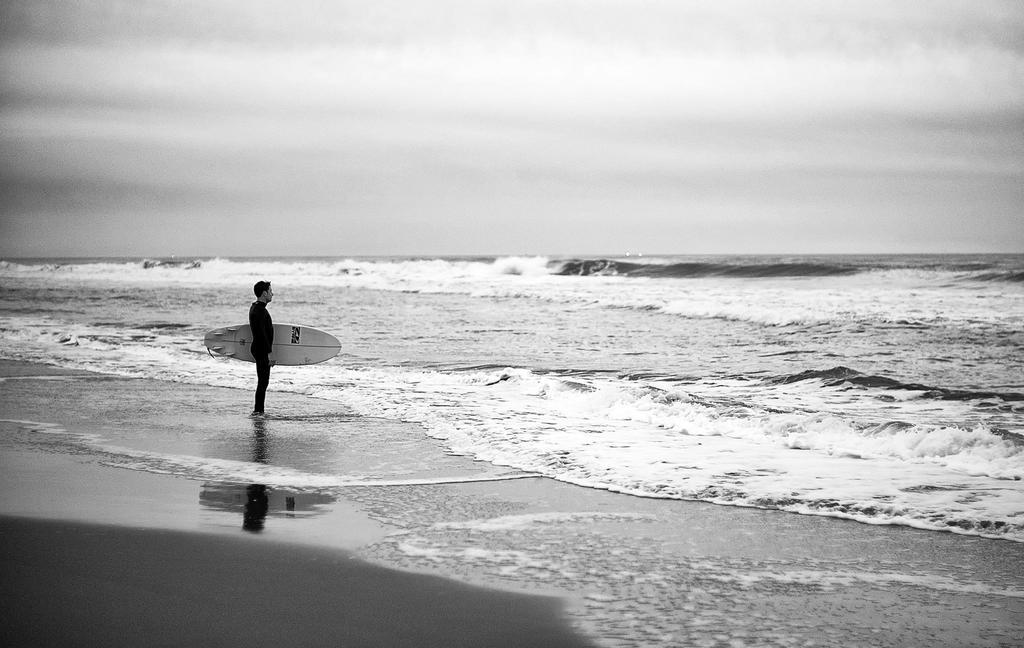Who is present in the image? There is a man in the picture. What is the man wearing? The man is wearing a black t-shirt. What is the man holding in the image? The man is holding a surfing board. What can be seen in the background of the image? There is water visible in the image. What is the man's focus in the image? The man is looking at the water. What type of verse is the man reciting in the image? There is no indication in the image that the man is reciting any verse, so it cannot be determined from the picture. 